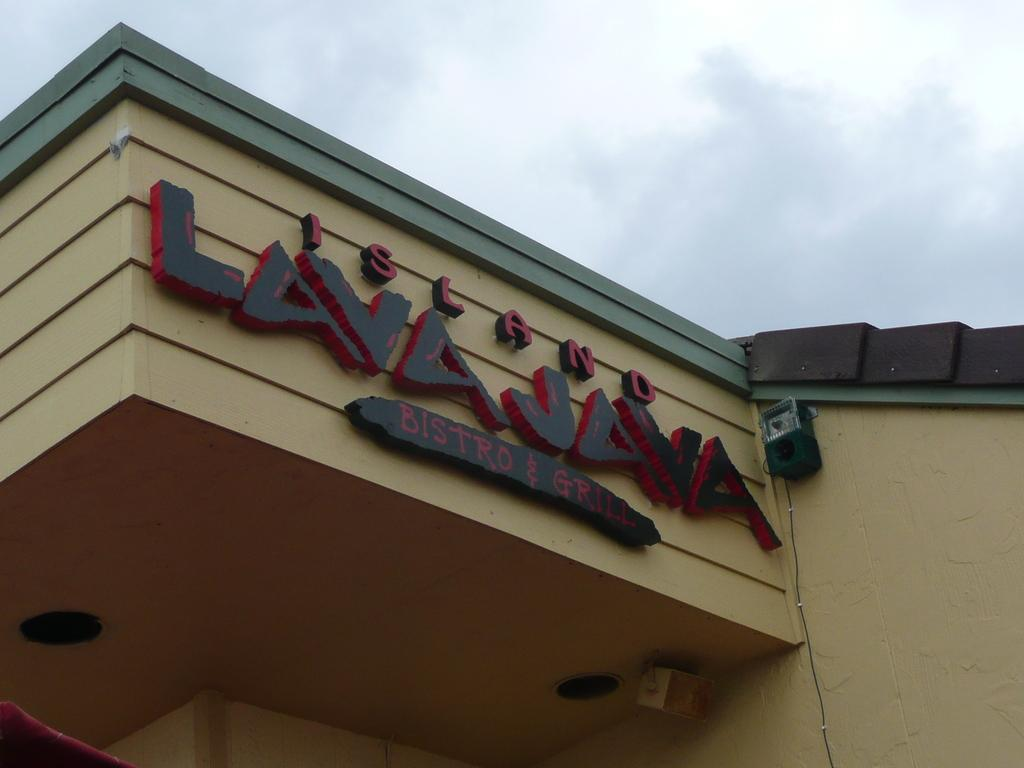What type of structure is visible in the image? There is a house in the image. What can be seen on the wall of the house? There is text on the wall of the house. What is visible at the top of the image? The sky is visible at the top of the image. What object is placed on the wall to the right side of the image? There is an object placed on the wall to the right side of the image. What type of crime is being committed in the image? There is no indication of any crime being committed in the image. What type of berry can be seen growing on the wall of the house? There are no berries visible in the image. 